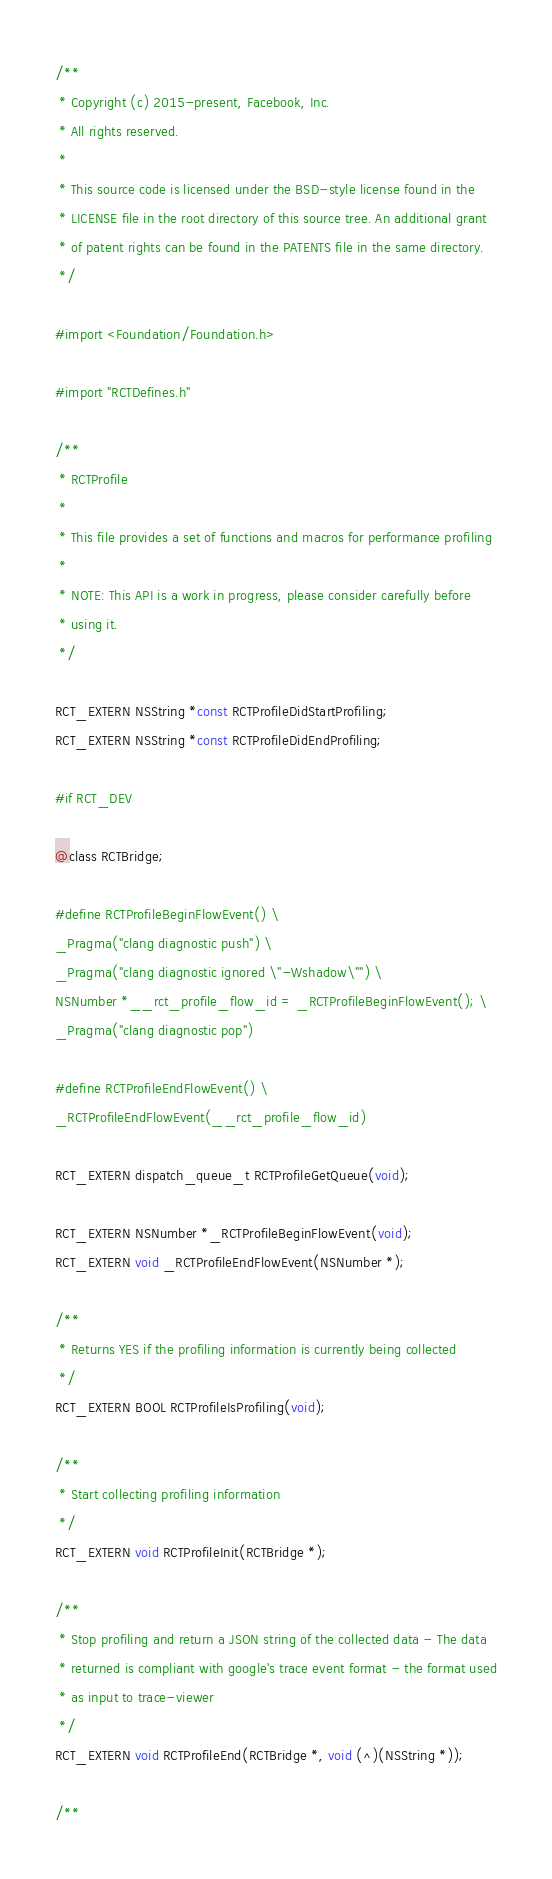Convert code to text. <code><loc_0><loc_0><loc_500><loc_500><_C_>/**
 * Copyright (c) 2015-present, Facebook, Inc.
 * All rights reserved.
 *
 * This source code is licensed under the BSD-style license found in the
 * LICENSE file in the root directory of this source tree. An additional grant
 * of patent rights can be found in the PATENTS file in the same directory.
 */

#import <Foundation/Foundation.h>

#import "RCTDefines.h"

/**
 * RCTProfile
 *
 * This file provides a set of functions and macros for performance profiling
 *
 * NOTE: This API is a work in progress, please consider carefully before
 * using it.
 */

RCT_EXTERN NSString *const RCTProfileDidStartProfiling;
RCT_EXTERN NSString *const RCTProfileDidEndProfiling;

#if RCT_DEV

@class RCTBridge;

#define RCTProfileBeginFlowEvent() \
_Pragma("clang diagnostic push") \
_Pragma("clang diagnostic ignored \"-Wshadow\"") \
NSNumber *__rct_profile_flow_id = _RCTProfileBeginFlowEvent(); \
_Pragma("clang diagnostic pop")

#define RCTProfileEndFlowEvent() \
_RCTProfileEndFlowEvent(__rct_profile_flow_id)

RCT_EXTERN dispatch_queue_t RCTProfileGetQueue(void);

RCT_EXTERN NSNumber *_RCTProfileBeginFlowEvent(void);
RCT_EXTERN void _RCTProfileEndFlowEvent(NSNumber *);

/**
 * Returns YES if the profiling information is currently being collected
 */
RCT_EXTERN BOOL RCTProfileIsProfiling(void);

/**
 * Start collecting profiling information
 */
RCT_EXTERN void RCTProfileInit(RCTBridge *);

/**
 * Stop profiling and return a JSON string of the collected data - The data
 * returned is compliant with google's trace event format - the format used
 * as input to trace-viewer
 */
RCT_EXTERN void RCTProfileEnd(RCTBridge *, void (^)(NSString *));

/**</code> 